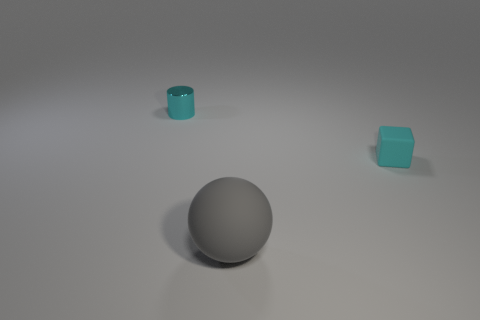There is a tiny shiny cylinder; does it have the same color as the tiny thing in front of the metal cylinder?
Offer a terse response. Yes. The object that is the same size as the cube is what color?
Offer a terse response. Cyan. Is the number of matte cubes less than the number of big metal objects?
Provide a short and direct response. No. There is a rubber object behind the gray rubber thing; what is its color?
Your answer should be compact. Cyan. What shape is the small object to the left of the rubber thing to the left of the cyan matte block?
Your answer should be compact. Cylinder. Is the big thing made of the same material as the cyan object behind the rubber cube?
Keep it short and to the point. No. What shape is the small matte object that is the same color as the tiny cylinder?
Your response must be concise. Cube. How many metal cylinders are the same size as the cyan block?
Make the answer very short. 1. Are there fewer matte balls behind the tiny cyan cylinder than big yellow shiny cubes?
Your response must be concise. No. What number of things are left of the tiny block?
Provide a succinct answer. 2. 